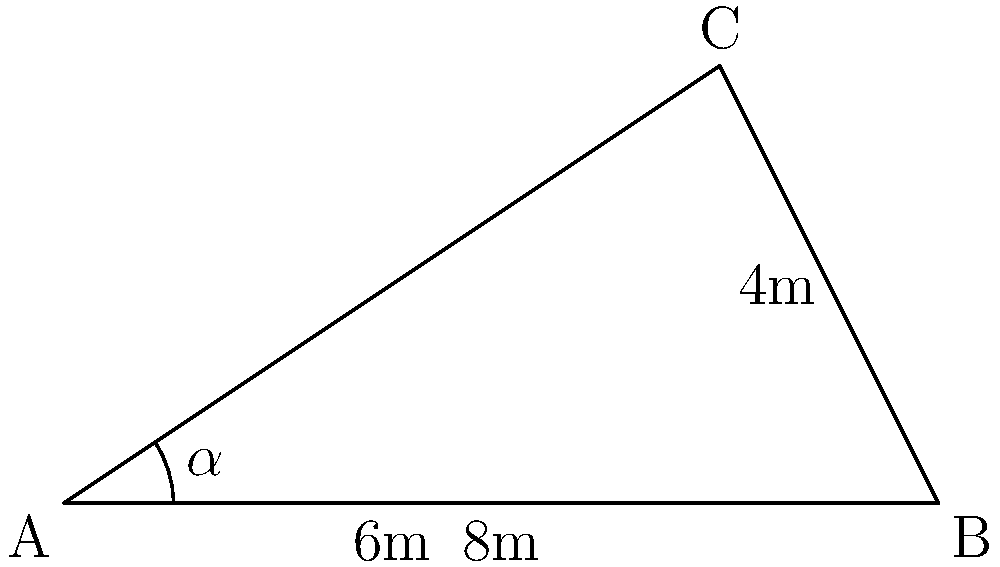A Celtic burial mound has an irregular triangular shape. The base of the mound measures 8 meters, and a perpendicular line from the opposite vertex to the base measures 4 meters. If this perpendicular line intersects the base 6 meters from one end, calculate the area of the burial mound. Round your answer to the nearest square meter. To solve this problem, we'll use trigonometric functions and the formula for the area of a triangle.

1) First, let's identify the known measurements:
   - Base (AB) = 8 meters
   - Height (CD) = 4 meters
   - AD = 6 meters
   - DB = 2 meters (8 - 6 = 2)

2) We can split the triangle into two right triangles: ACD and BCD.

3) For triangle ACD:
   $\tan(\alpha) = \frac{4}{6} = \frac{2}{3}$
   $\alpha = \arctan(\frac{2}{3}) \approx 33.69°$

4) Now we can find the area of the whole triangle using the formula:
   $\text{Area} = \frac{1}{2} \times \text{base} \times \text{height}$

5) Substituting our values:
   $\text{Area} = \frac{1}{2} \times 8 \times 4 = 16$ square meters

6) Rounding to the nearest square meter:
   $\text{Area} \approx 16$ square meters
Answer: 16 square meters 